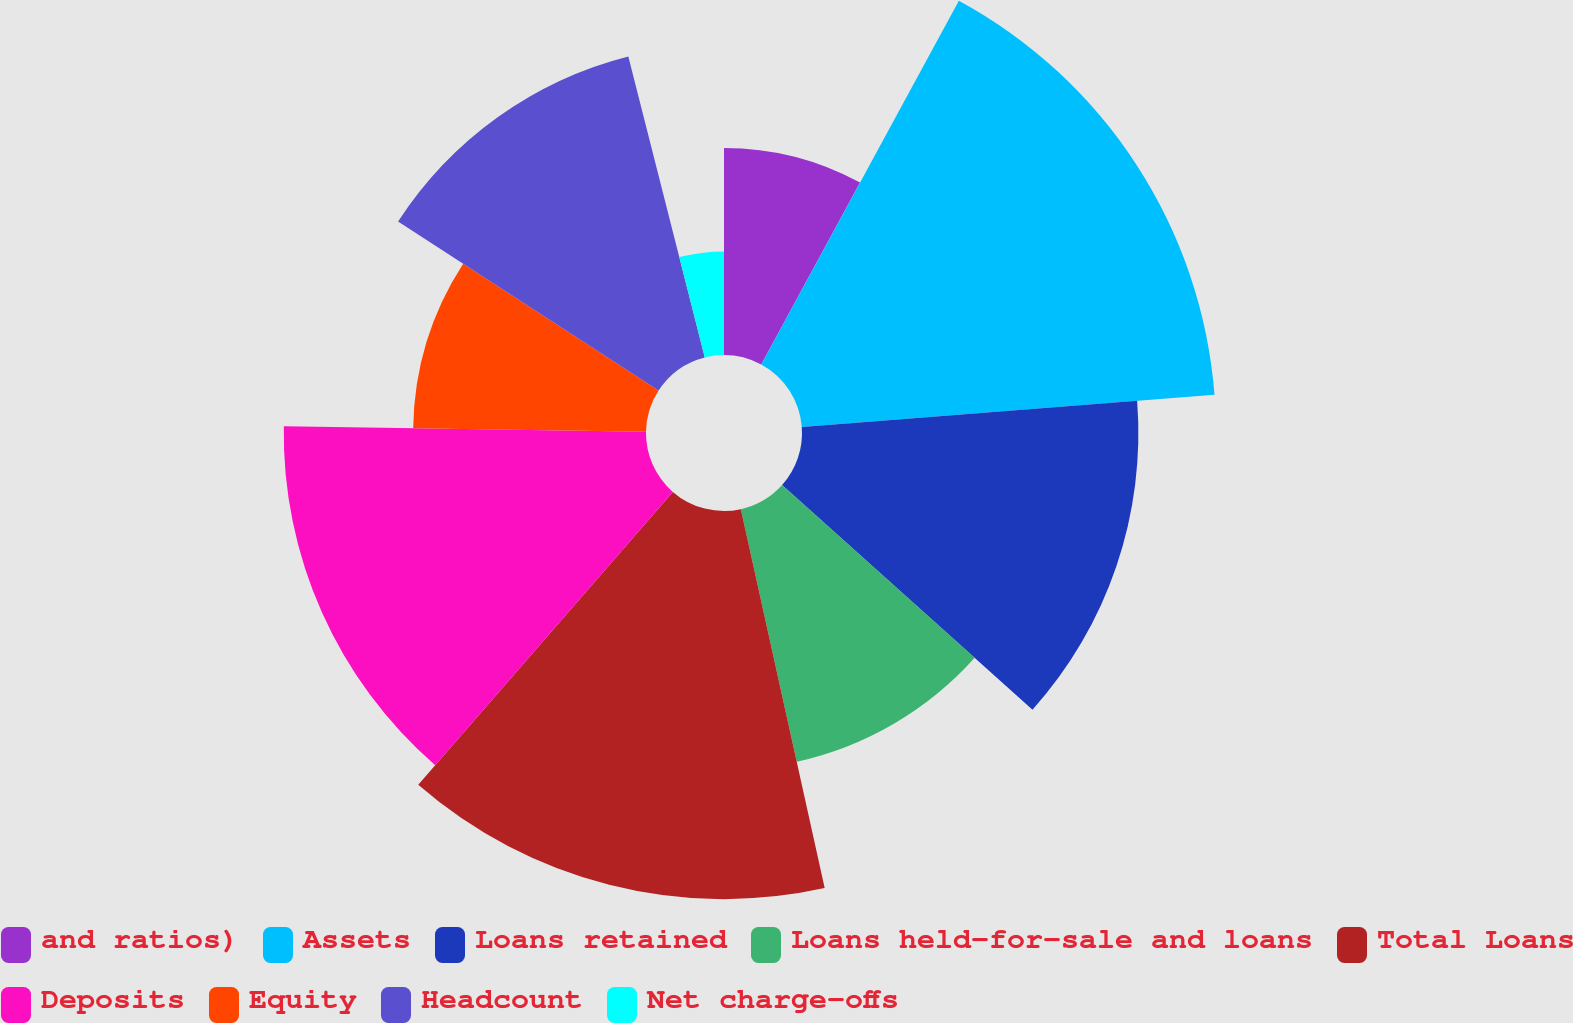Convert chart. <chart><loc_0><loc_0><loc_500><loc_500><pie_chart><fcel>and ratios)<fcel>Assets<fcel>Loans retained<fcel>Loans held-for-sale and loans<fcel>Total Loans<fcel>Deposits<fcel>Equity<fcel>Headcount<fcel>Net charge-offs<nl><fcel>7.92%<fcel>15.84%<fcel>12.87%<fcel>9.9%<fcel>14.85%<fcel>13.86%<fcel>8.91%<fcel>11.88%<fcel>3.96%<nl></chart> 